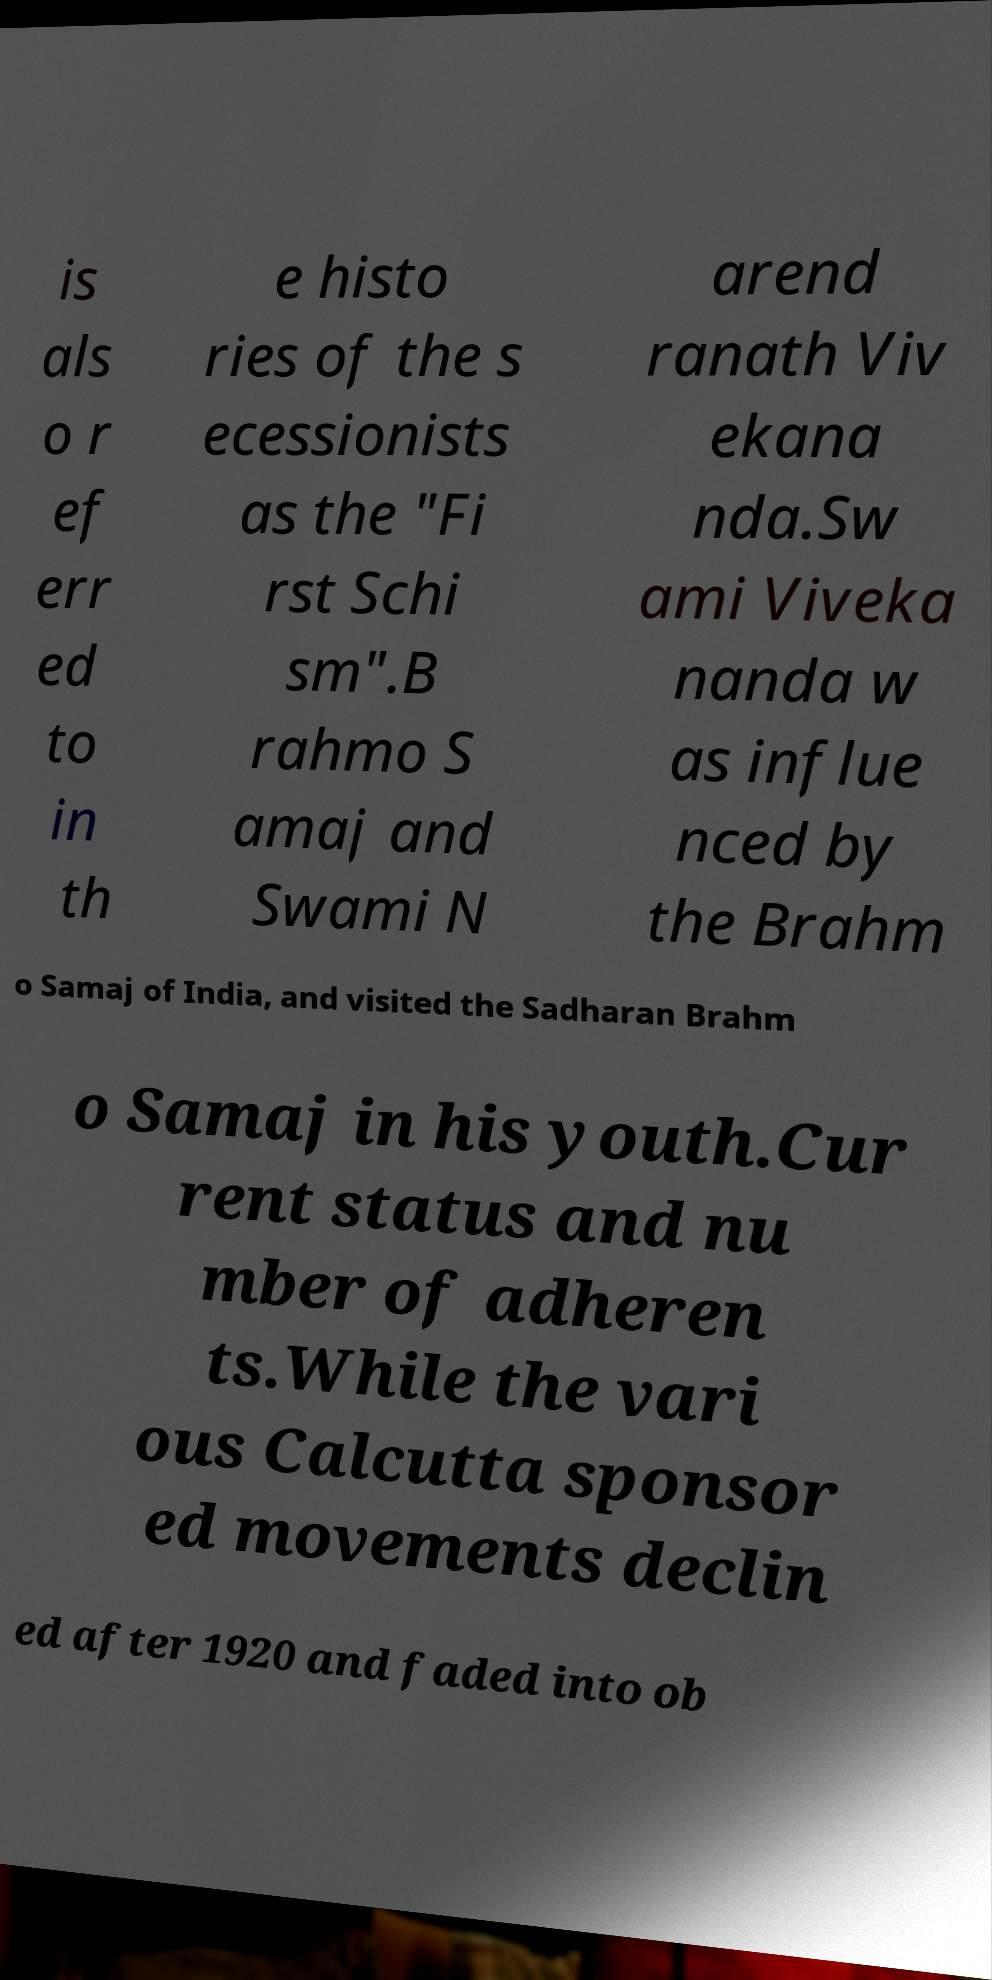Please identify and transcribe the text found in this image. is als o r ef err ed to in th e histo ries of the s ecessionists as the "Fi rst Schi sm".B rahmo S amaj and Swami N arend ranath Viv ekana nda.Sw ami Viveka nanda w as influe nced by the Brahm o Samaj of India, and visited the Sadharan Brahm o Samaj in his youth.Cur rent status and nu mber of adheren ts.While the vari ous Calcutta sponsor ed movements declin ed after 1920 and faded into ob 